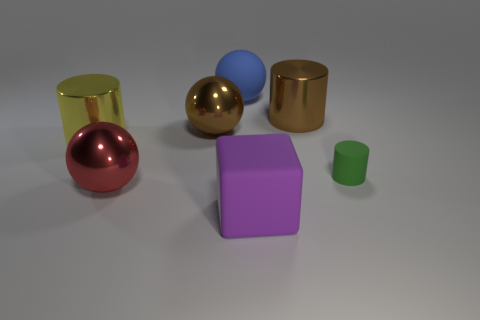Is there anything else that has the same size as the green cylinder?
Offer a terse response. No. Does the brown cylinder have the same size as the shiny thing in front of the yellow shiny cylinder?
Offer a very short reply. Yes. What number of large spheres are in front of the green matte cylinder right of the large shiny ball to the right of the large red thing?
Your answer should be very brief. 1. There is a brown metal cylinder; are there any large brown shiny cylinders left of it?
Ensure brevity in your answer.  No. The small green object is what shape?
Your response must be concise. Cylinder. What is the shape of the matte object in front of the tiny green cylinder right of the big matte thing on the left side of the large purple rubber block?
Keep it short and to the point. Cube. How many other objects are there of the same shape as the large blue rubber object?
Your answer should be compact. 2. What material is the large brown thing that is to the right of the purple thing to the left of the big brown metallic cylinder?
Make the answer very short. Metal. Are the big purple cube and the large cylinder left of the big red shiny thing made of the same material?
Make the answer very short. No. There is a cylinder that is left of the small green cylinder and on the right side of the red metallic sphere; what material is it made of?
Your response must be concise. Metal. 